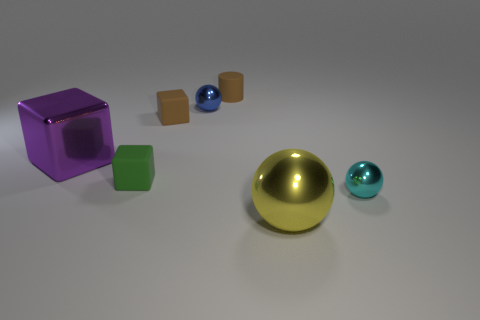There's a shadow beneath each object; what can you infer about the light source? The shadows are relatively short and to the right of each object, suggesting a light source positioned to the left and slightly above the scene. 